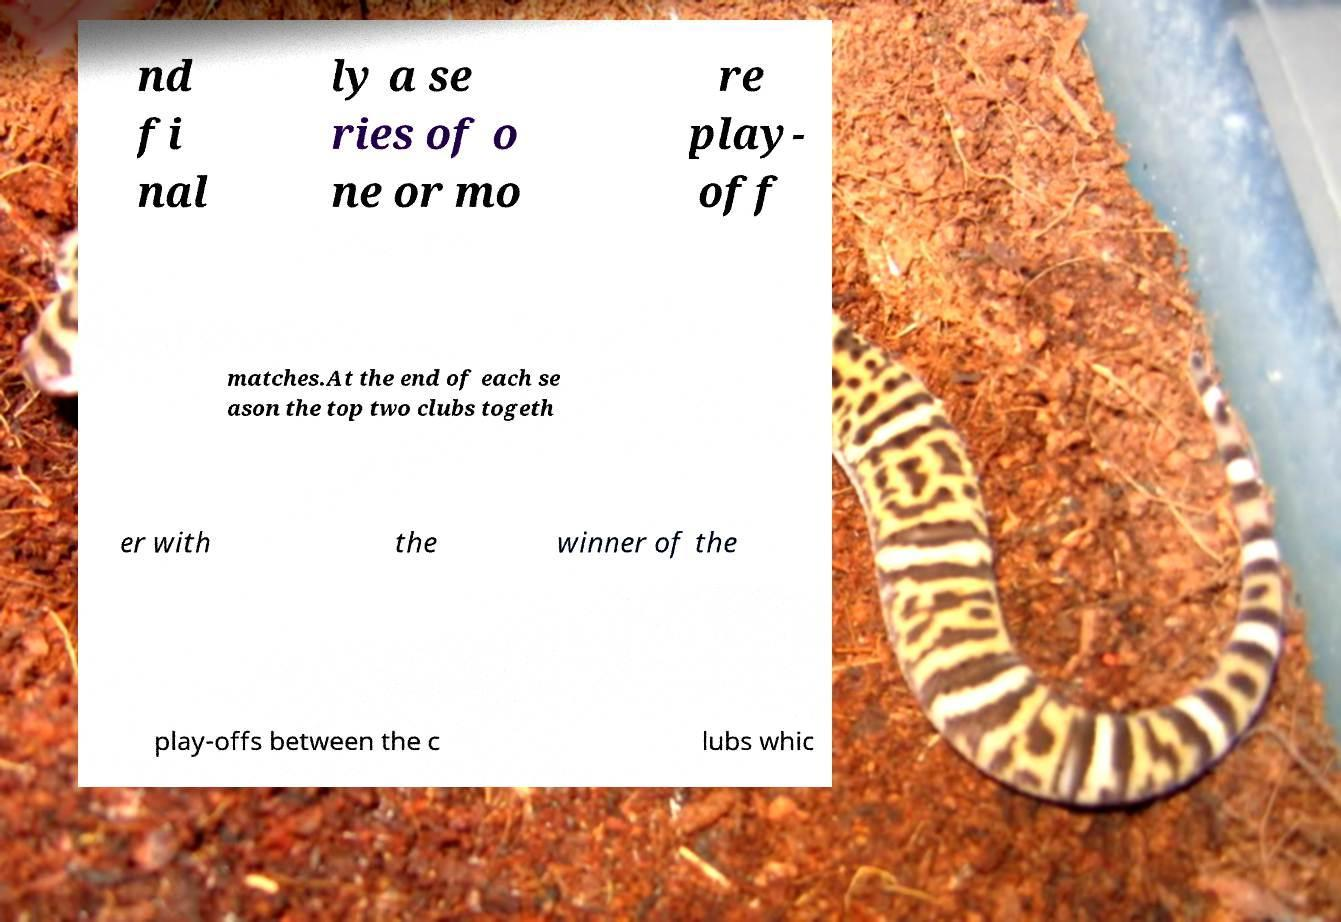Can you read and provide the text displayed in the image?This photo seems to have some interesting text. Can you extract and type it out for me? nd fi nal ly a se ries of o ne or mo re play- off matches.At the end of each se ason the top two clubs togeth er with the winner of the play-offs between the c lubs whic 